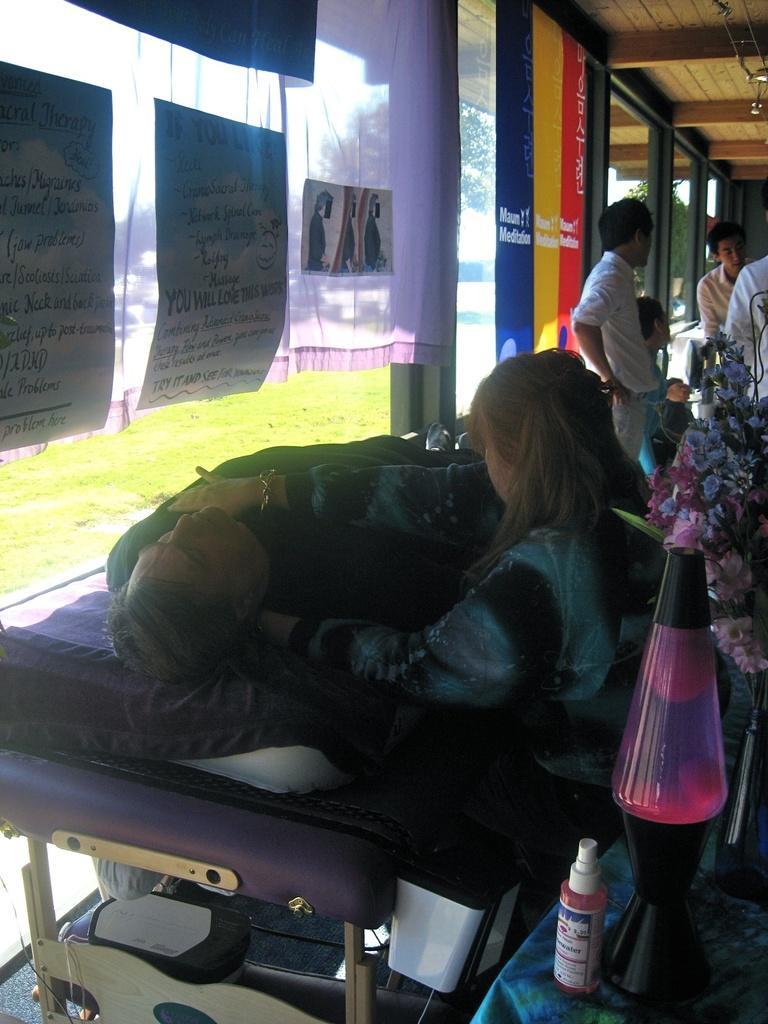Could you give a brief overview of what you see in this image? In this image I can see people among them this man is lying on a bed. Here I can see a bottle and some other objects. In the background I can see curtains, windows and the grass. 